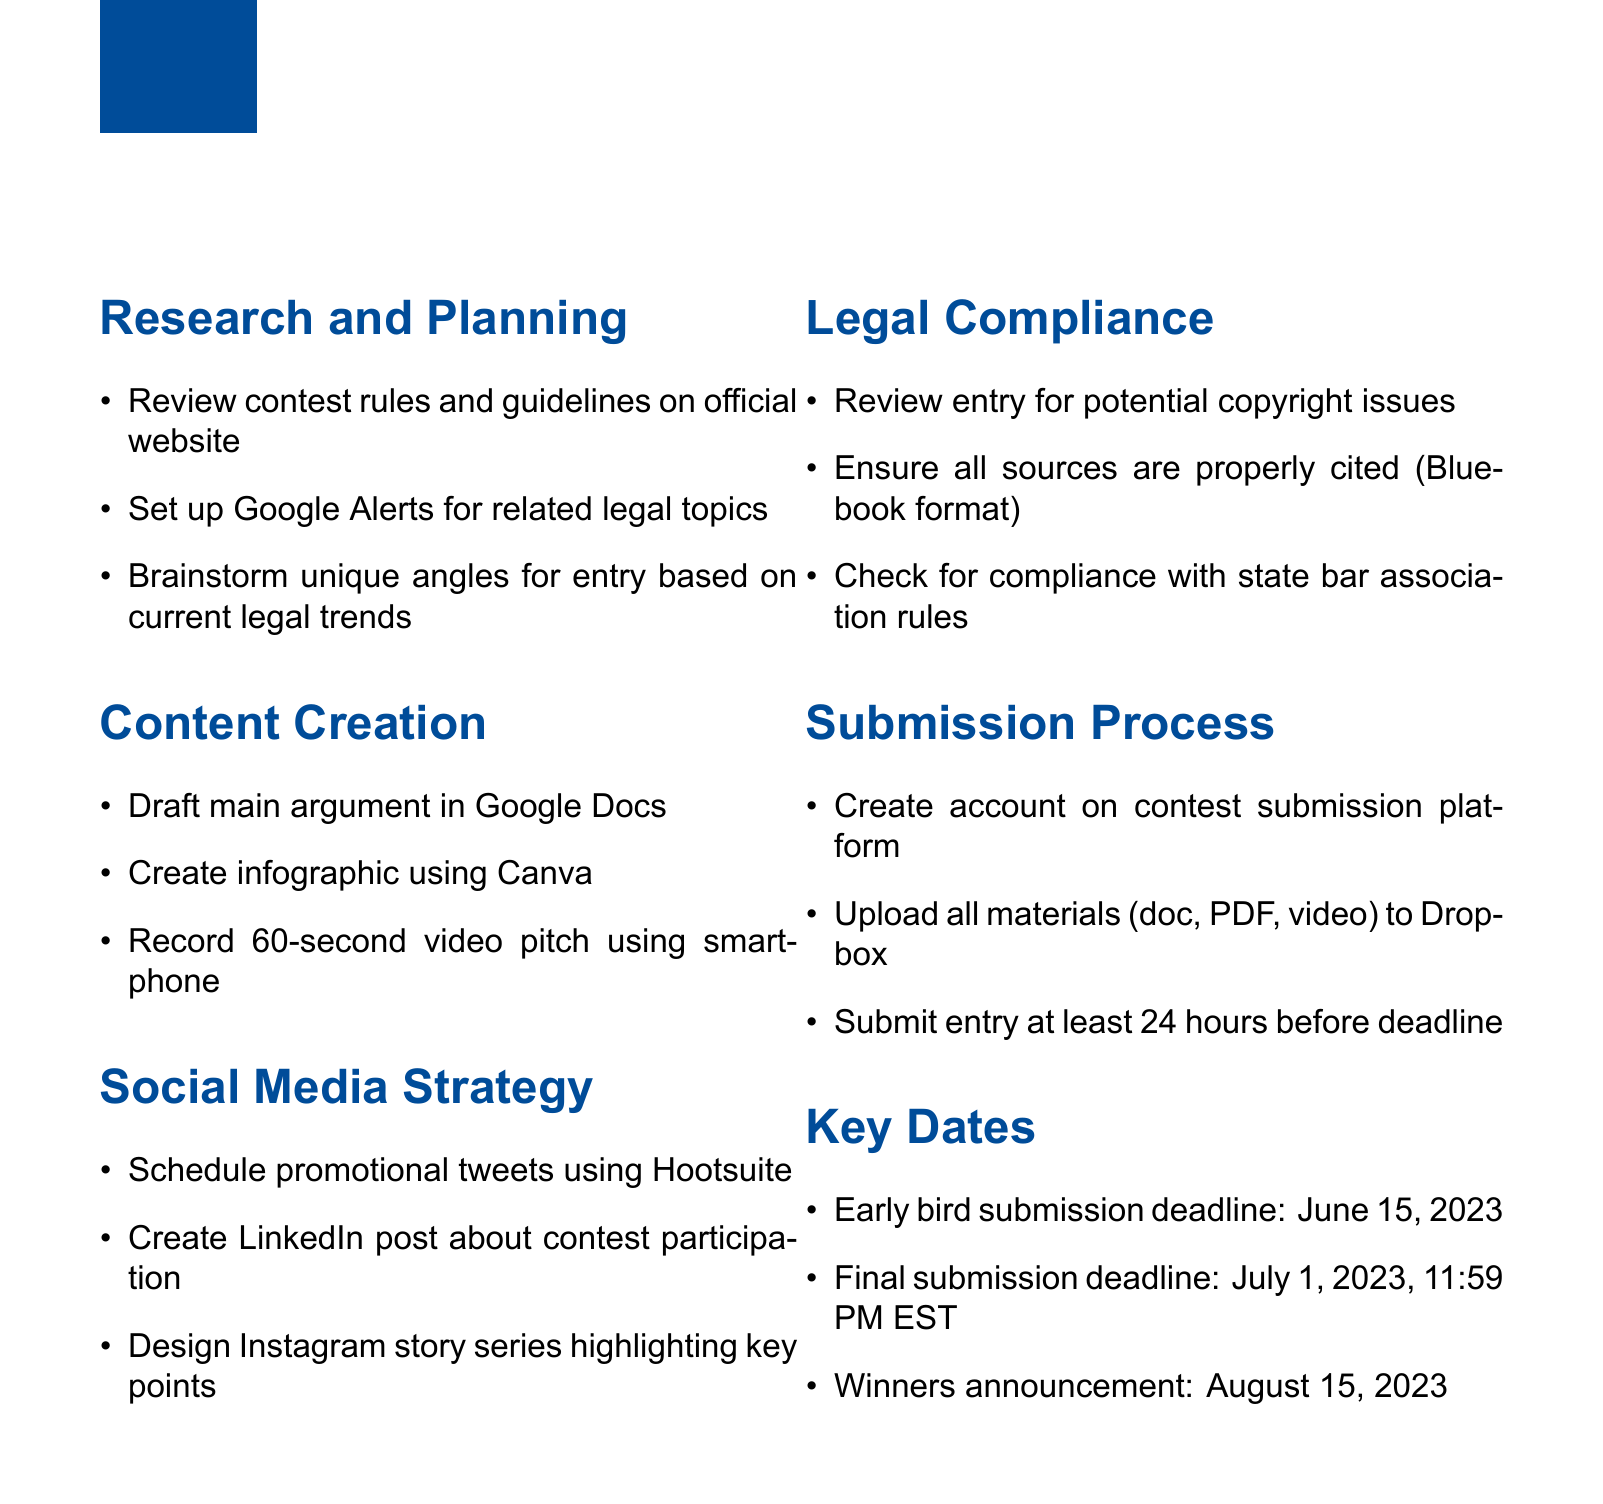What is the first item in the "Research and Planning" section? The first item listed in the "Research and Planning" section specifies reviewing contest rules on the official website.
Answer: Review contest rules and guidelines on official website What is the tool suggested for creating an infographic? The document suggests using Canva as the tool for creating an infographic.
Answer: Canva What is the final submission deadline? The final submission deadline is clearly stated as July 1, 2023, at 11:59 PM EST.
Answer: July 1, 2023, 11:59 PM EST How many items are listed under "Legal Compliance"? There are three items listed under "Legal Compliance", indicating specific compliance checks to be performed.
Answer: 3 What is one of the key dates for winners announcement? The winners announcement is scheduled for August 15, 2023, which is a critical date for participants.
Answer: August 15, 2023 What social media platform should be used for scheduling tweets? The document specifies using Hootsuite for scheduling promotional tweets.
Answer: Hootsuite What type of video is suggested to be recorded? The type of video mentioned is a 60-second video pitch, which is a concise format for contest entries.
Answer: 60-second video pitch What should be ensured regarding sources in the content? The document emphasizes the importance of proper citation of all sources in Bluebook format for legal entries.
Answer: Bluebook format 